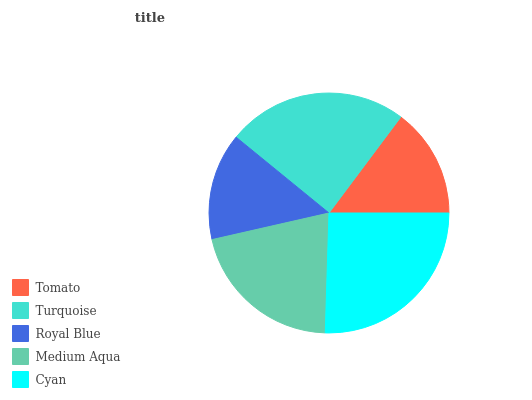Is Royal Blue the minimum?
Answer yes or no. Yes. Is Cyan the maximum?
Answer yes or no. Yes. Is Turquoise the minimum?
Answer yes or no. No. Is Turquoise the maximum?
Answer yes or no. No. Is Turquoise greater than Tomato?
Answer yes or no. Yes. Is Tomato less than Turquoise?
Answer yes or no. Yes. Is Tomato greater than Turquoise?
Answer yes or no. No. Is Turquoise less than Tomato?
Answer yes or no. No. Is Medium Aqua the high median?
Answer yes or no. Yes. Is Medium Aqua the low median?
Answer yes or no. Yes. Is Turquoise the high median?
Answer yes or no. No. Is Turquoise the low median?
Answer yes or no. No. 